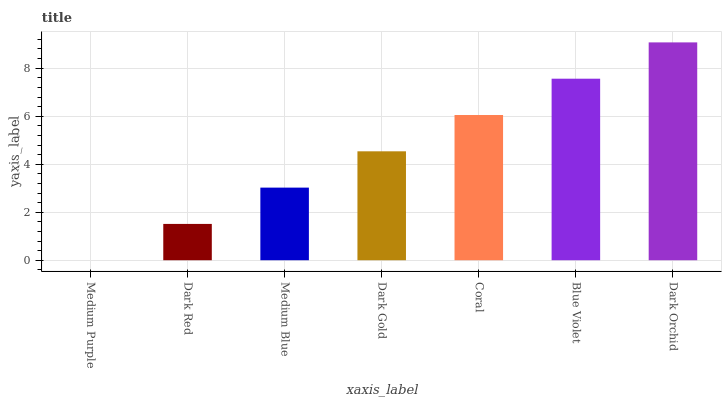Is Medium Purple the minimum?
Answer yes or no. Yes. Is Dark Orchid the maximum?
Answer yes or no. Yes. Is Dark Red the minimum?
Answer yes or no. No. Is Dark Red the maximum?
Answer yes or no. No. Is Dark Red greater than Medium Purple?
Answer yes or no. Yes. Is Medium Purple less than Dark Red?
Answer yes or no. Yes. Is Medium Purple greater than Dark Red?
Answer yes or no. No. Is Dark Red less than Medium Purple?
Answer yes or no. No. Is Dark Gold the high median?
Answer yes or no. Yes. Is Dark Gold the low median?
Answer yes or no. Yes. Is Medium Blue the high median?
Answer yes or no. No. Is Coral the low median?
Answer yes or no. No. 